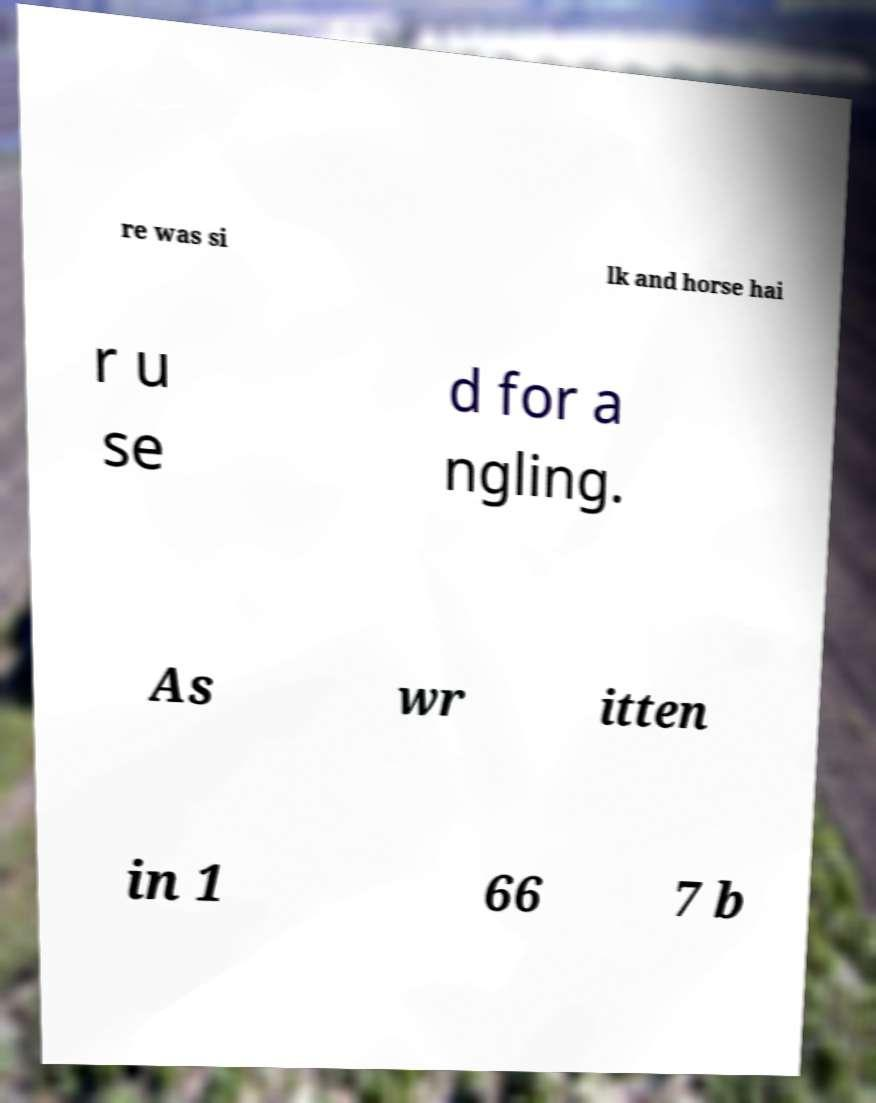For documentation purposes, I need the text within this image transcribed. Could you provide that? re was si lk and horse hai r u se d for a ngling. As wr itten in 1 66 7 b 